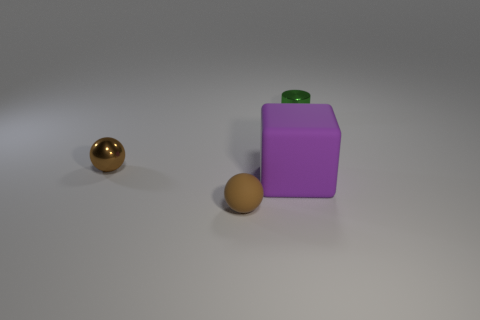Add 1 big cyan shiny spheres. How many objects exist? 5 Subtract all cubes. How many objects are left? 3 Subtract 1 blocks. How many blocks are left? 0 Add 1 big green objects. How many big green objects exist? 1 Subtract 1 purple blocks. How many objects are left? 3 Subtract all gray balls. Subtract all yellow blocks. How many balls are left? 2 Subtract all small metallic cylinders. Subtract all big things. How many objects are left? 2 Add 3 purple rubber blocks. How many purple rubber blocks are left? 4 